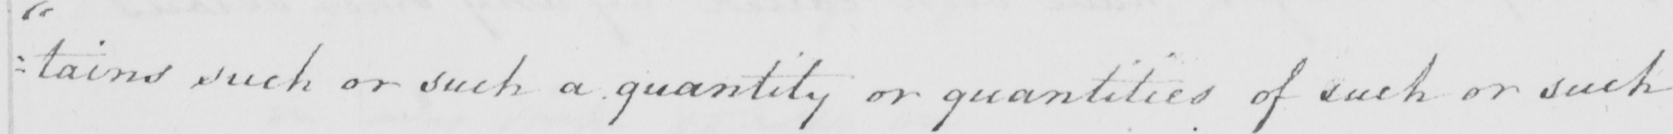Please provide the text content of this handwritten line. : tains such or such a quantity or quantities of such or such 